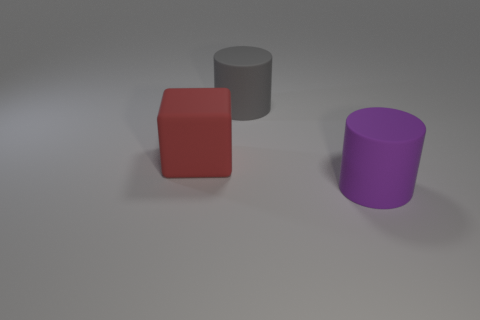What number of big things are either yellow spheres or gray things?
Provide a short and direct response. 1. Is there a big gray cylinder made of the same material as the big block?
Give a very brief answer. Yes. There is a cylinder that is in front of the gray cylinder; does it have the same size as the large gray object?
Provide a succinct answer. Yes. Is there a large rubber cylinder behind the red thing in front of the cylinder behind the purple rubber thing?
Keep it short and to the point. Yes. What number of metallic things are either small cyan spheres or large red blocks?
Offer a terse response. 0. How many other things are the same shape as the large red object?
Your answer should be very brief. 0. Is the number of large gray cylinders greater than the number of small gray things?
Keep it short and to the point. Yes. There is a object that is behind the big matte object that is to the left of the large matte cylinder that is behind the large red object; what is its size?
Ensure brevity in your answer.  Large. What is the size of the matte object in front of the big red cube?
Your answer should be very brief. Large. What number of objects are either gray rubber things or big cylinders that are behind the purple matte object?
Make the answer very short. 1. 